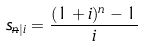<formula> <loc_0><loc_0><loc_500><loc_500>s _ { \overline { n } | i } = \frac { ( 1 + i ) ^ { n } - 1 } { i }</formula> 